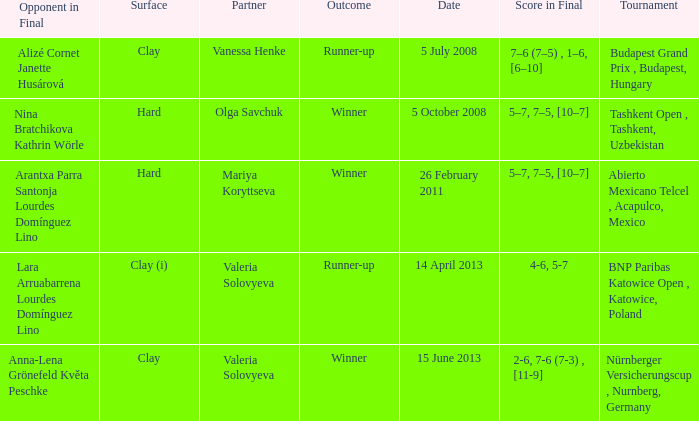Name the outcome that had an opponent in final of nina bratchikova kathrin wörle Winner. 